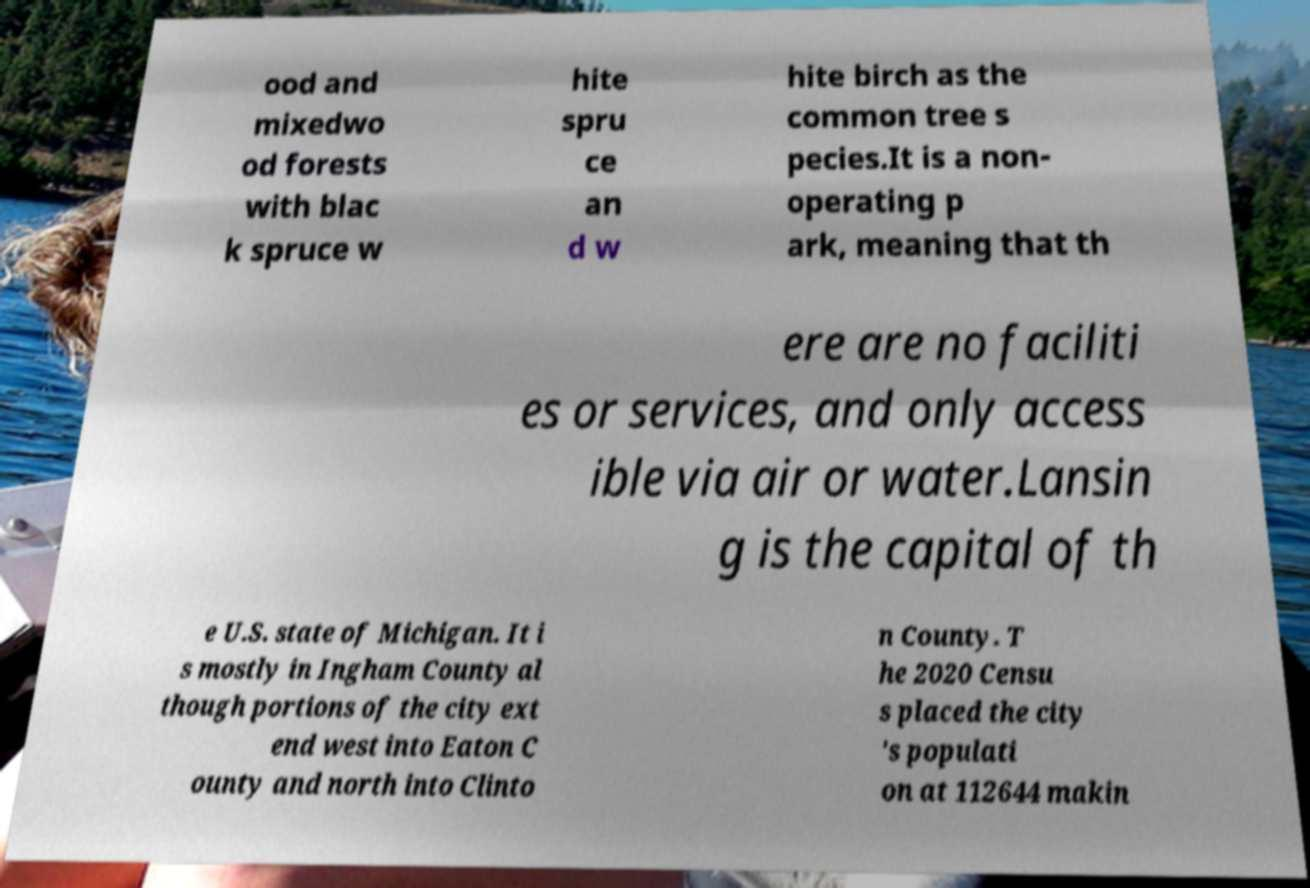There's text embedded in this image that I need extracted. Can you transcribe it verbatim? ood and mixedwo od forests with blac k spruce w hite spru ce an d w hite birch as the common tree s pecies.It is a non- operating p ark, meaning that th ere are no faciliti es or services, and only access ible via air or water.Lansin g is the capital of th e U.S. state of Michigan. It i s mostly in Ingham County al though portions of the city ext end west into Eaton C ounty and north into Clinto n County. T he 2020 Censu s placed the city 's populati on at 112644 makin 